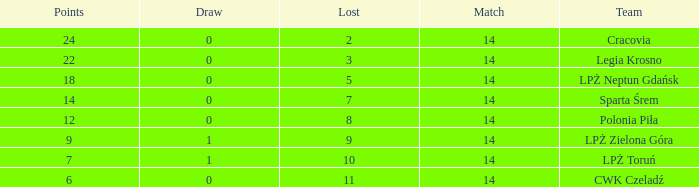What is the sum for the match with a draw less than 0? None. 